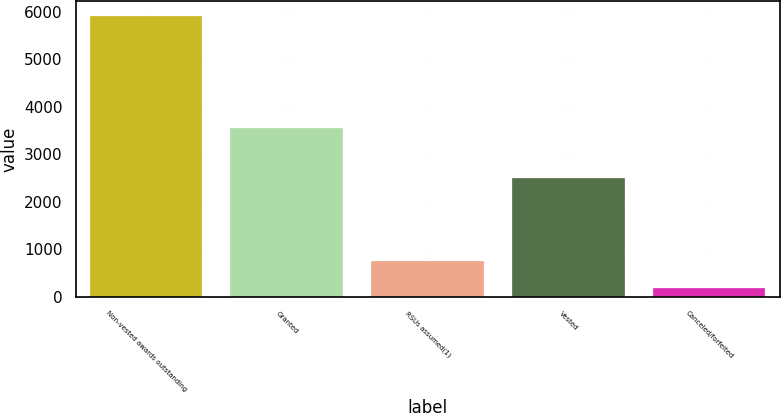Convert chart. <chart><loc_0><loc_0><loc_500><loc_500><bar_chart><fcel>Non-vested awards outstanding<fcel>Granted<fcel>RSUs assumed(1)<fcel>Vested<fcel>Canceled/forfeited<nl><fcel>5921<fcel>3560<fcel>755.9<fcel>2502<fcel>182<nl></chart> 